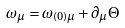Convert formula to latex. <formula><loc_0><loc_0><loc_500><loc_500>\omega _ { \mu } = \omega _ { ( 0 ) \mu } + \partial _ { \mu } \Theta</formula> 